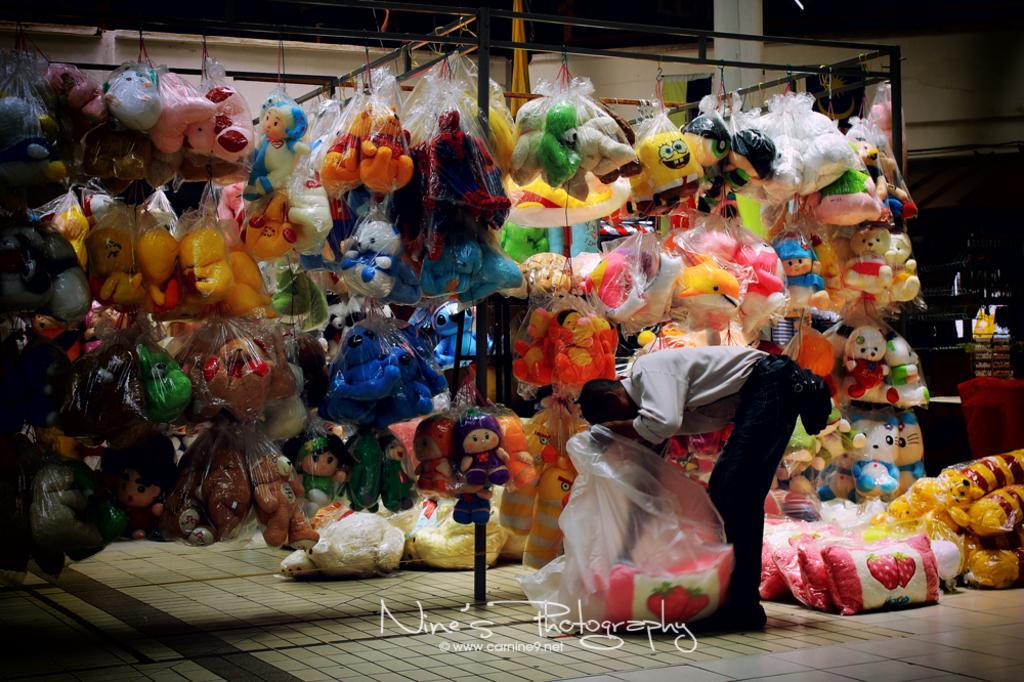How would you summarize this image in a sentence or two? In this image, we can see so many soft toys are wrapped with covers and they are hanging. Here we can see rods, few objects, wall and pillar. On the right side of the image, we can see a person is standing and holding a cover on the floor. At the bottom of the image, we can see a watermark. 